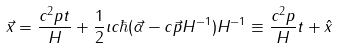Convert formula to latex. <formula><loc_0><loc_0><loc_500><loc_500>\vec { x } = \frac { c ^ { 2 } p t } { H } + \frac { 1 } { 2 } \imath c \hbar { ( } \vec { \alpha } - c \vec { p } H ^ { - 1 } ) H ^ { - 1 } \equiv \frac { c ^ { 2 } p } { H } t + \hat { x }</formula> 